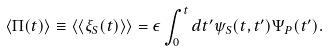Convert formula to latex. <formula><loc_0><loc_0><loc_500><loc_500>\langle \Pi ( t ) \rangle \equiv \langle \langle \xi _ { S } ( t ) \rangle \rangle = \epsilon \int _ { 0 } ^ { t } d t ^ { \prime } \psi _ { S } ( t , t ^ { \prime } ) \Psi _ { P } ( t ^ { \prime } ) .</formula> 